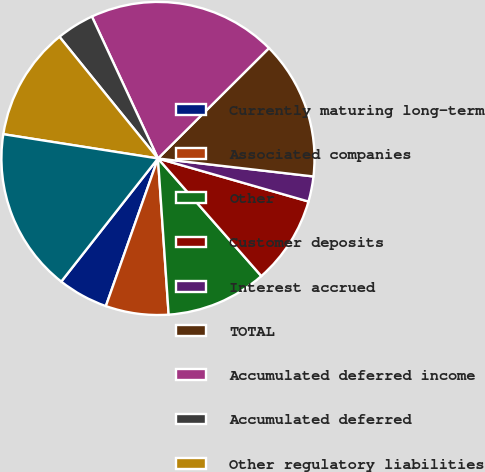<chart> <loc_0><loc_0><loc_500><loc_500><pie_chart><fcel>Currently maturing long-term<fcel>Associated companies<fcel>Other<fcel>Customer deposits<fcel>Interest accrued<fcel>TOTAL<fcel>Accumulated deferred income<fcel>Accumulated deferred<fcel>Other regulatory liabilities<fcel>Decommissioning<nl><fcel>5.2%<fcel>6.49%<fcel>10.39%<fcel>9.09%<fcel>2.6%<fcel>14.29%<fcel>19.48%<fcel>3.9%<fcel>11.69%<fcel>16.88%<nl></chart> 